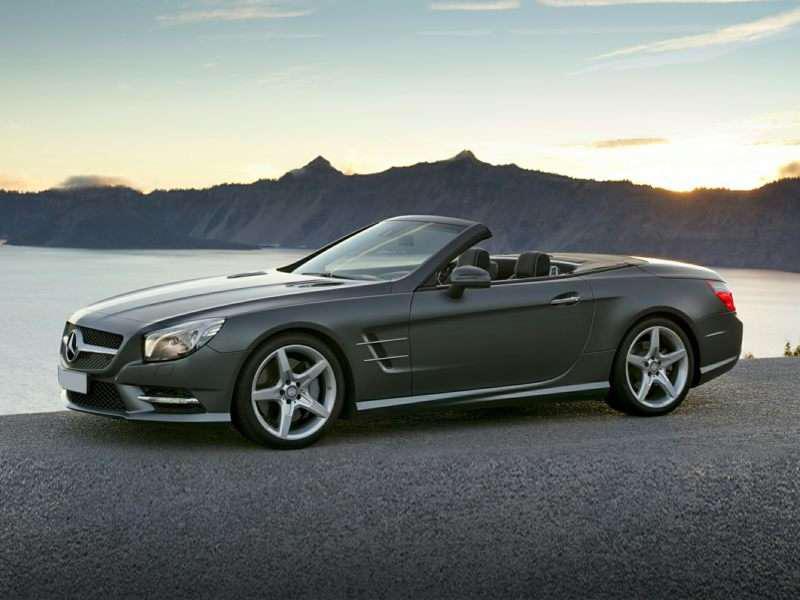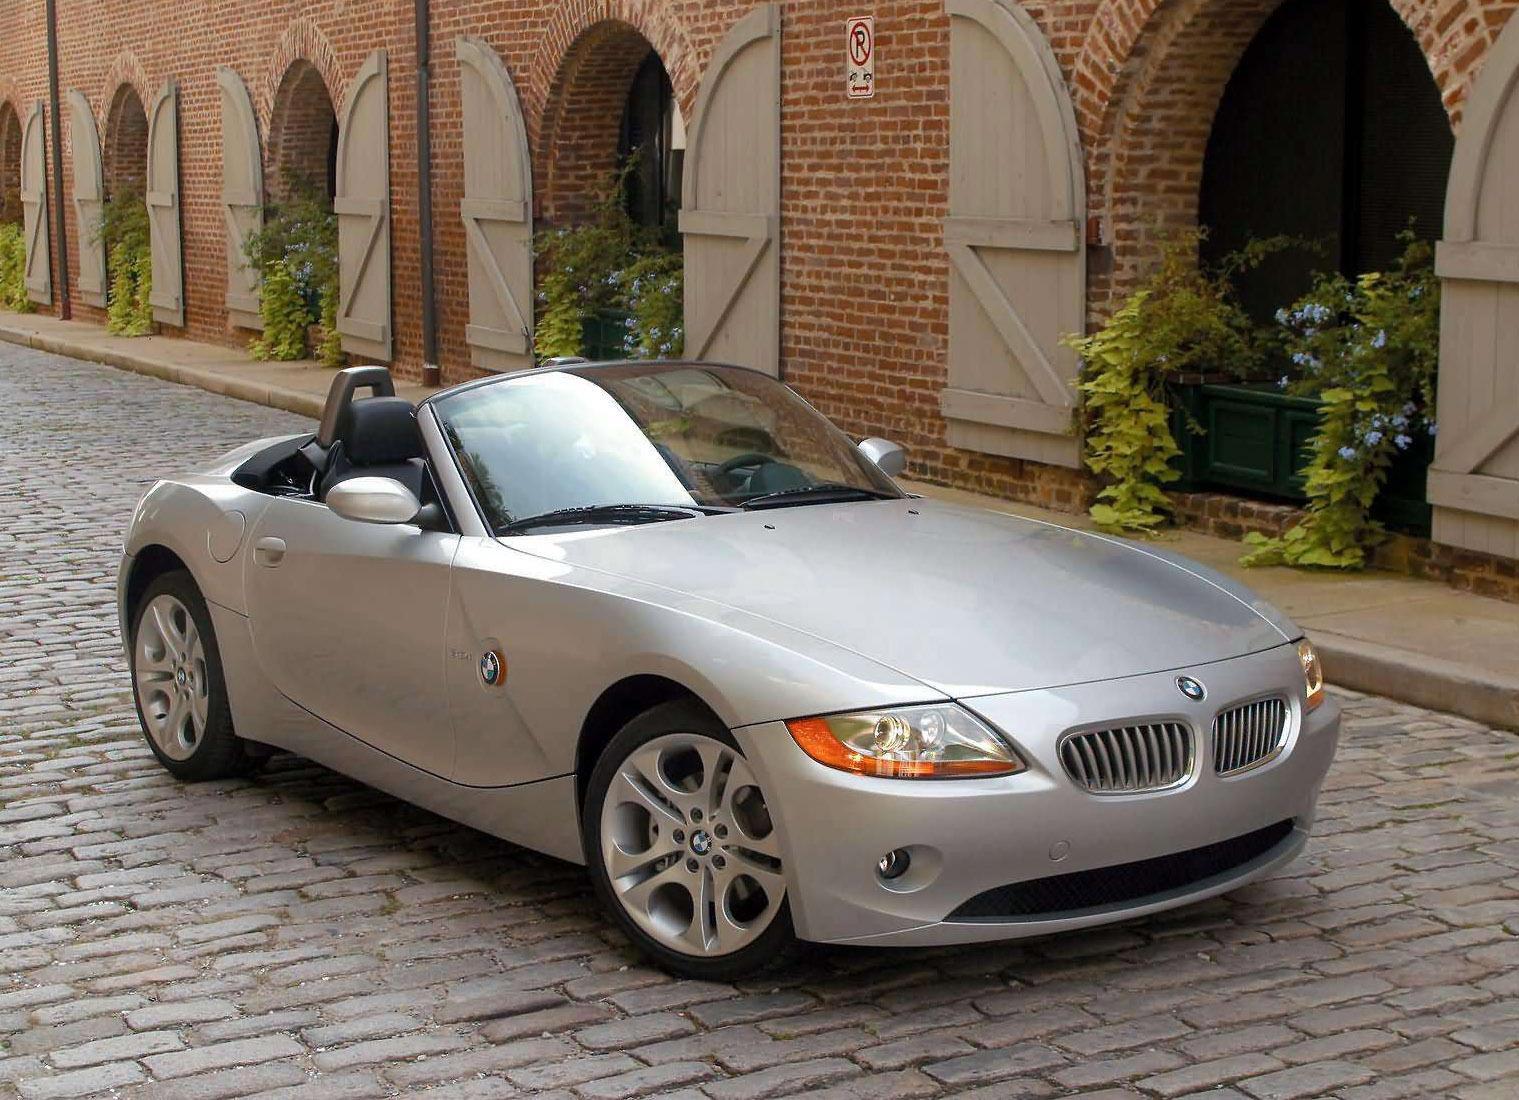The first image is the image on the left, the second image is the image on the right. Examine the images to the left and right. Is the description "There is a blue car facing right in the right image." accurate? Answer yes or no. No. The first image is the image on the left, the second image is the image on the right. For the images displayed, is the sentence "There Is a single apple red car with the top down and thin tires facing left on the road." factually correct? Answer yes or no. No. 